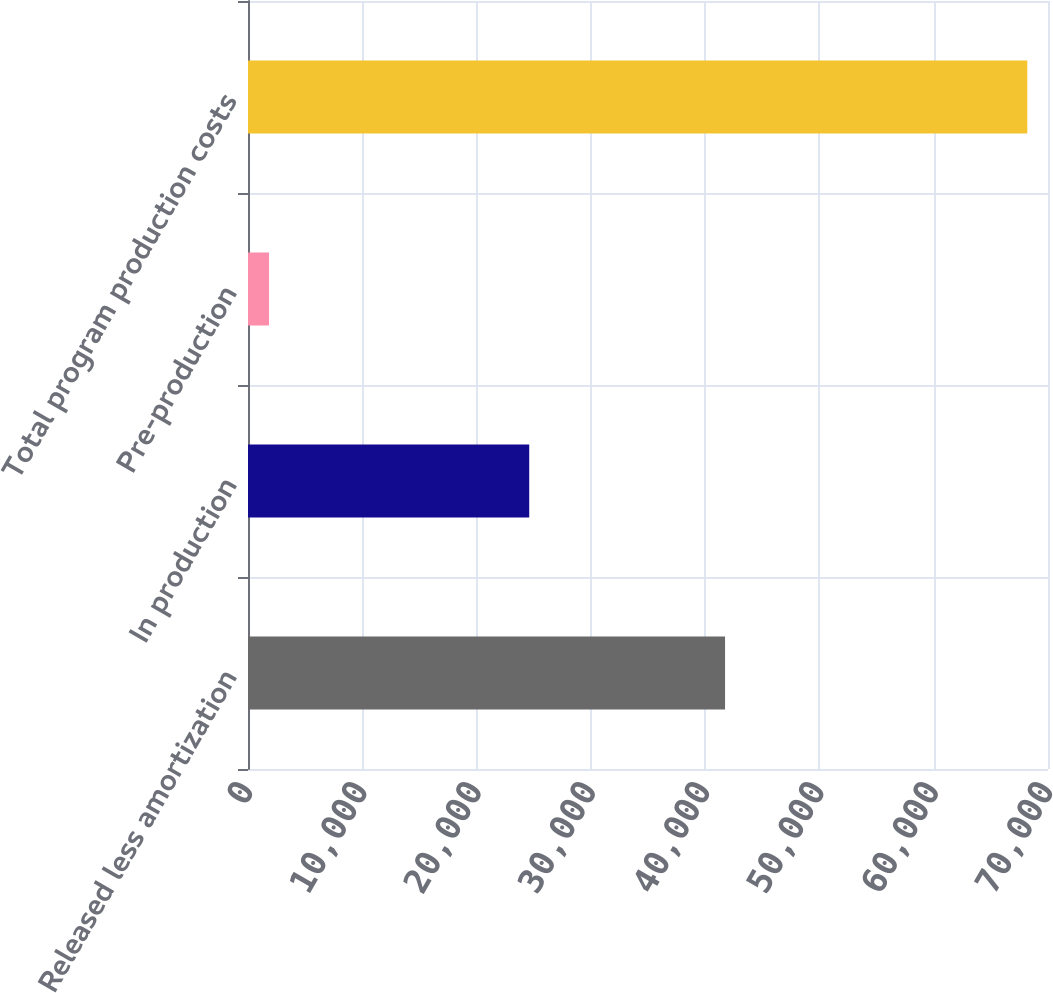<chart> <loc_0><loc_0><loc_500><loc_500><bar_chart><fcel>Released less amortization<fcel>In production<fcel>Pre-production<fcel>Total program production costs<nl><fcel>41742<fcel>24607<fcel>1841<fcel>68190<nl></chart> 